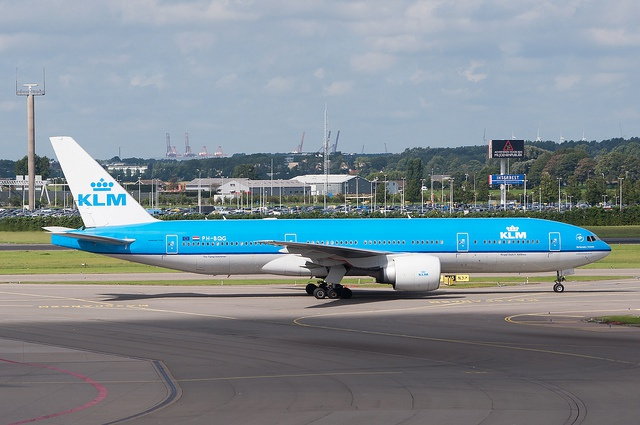Describe the objects in this image and their specific colors. I can see airplane in darkgray, lightblue, white, and gray tones, car in darkgray, black, gray, and darkblue tones, car in darkgray, gray, and lightgray tones, car in darkgray, gray, black, and darkgreen tones, and car in darkgray, gray, and darkblue tones in this image. 